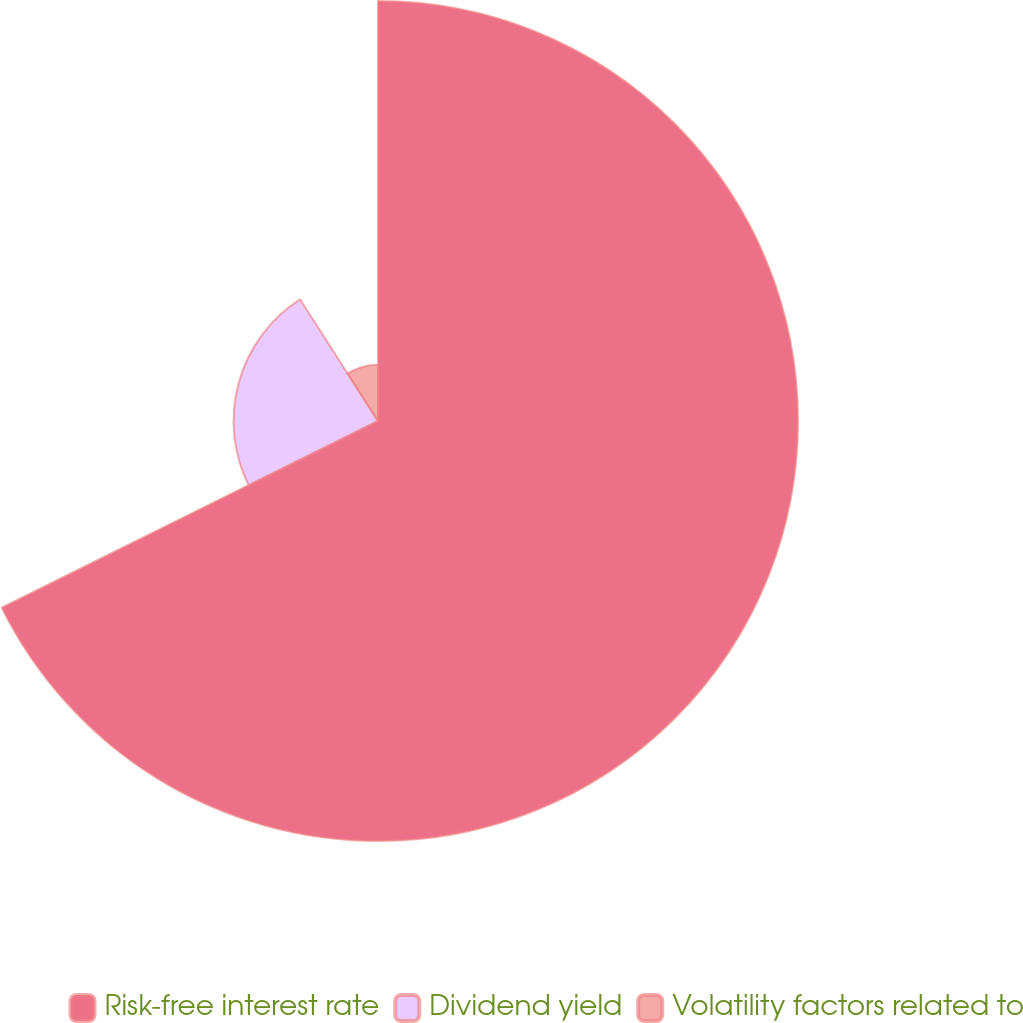<chart> <loc_0><loc_0><loc_500><loc_500><pie_chart><fcel>Risk-free interest rate<fcel>Dividend yield<fcel>Volatility factors related to<nl><fcel>67.67%<fcel>23.26%<fcel>9.07%<nl></chart> 